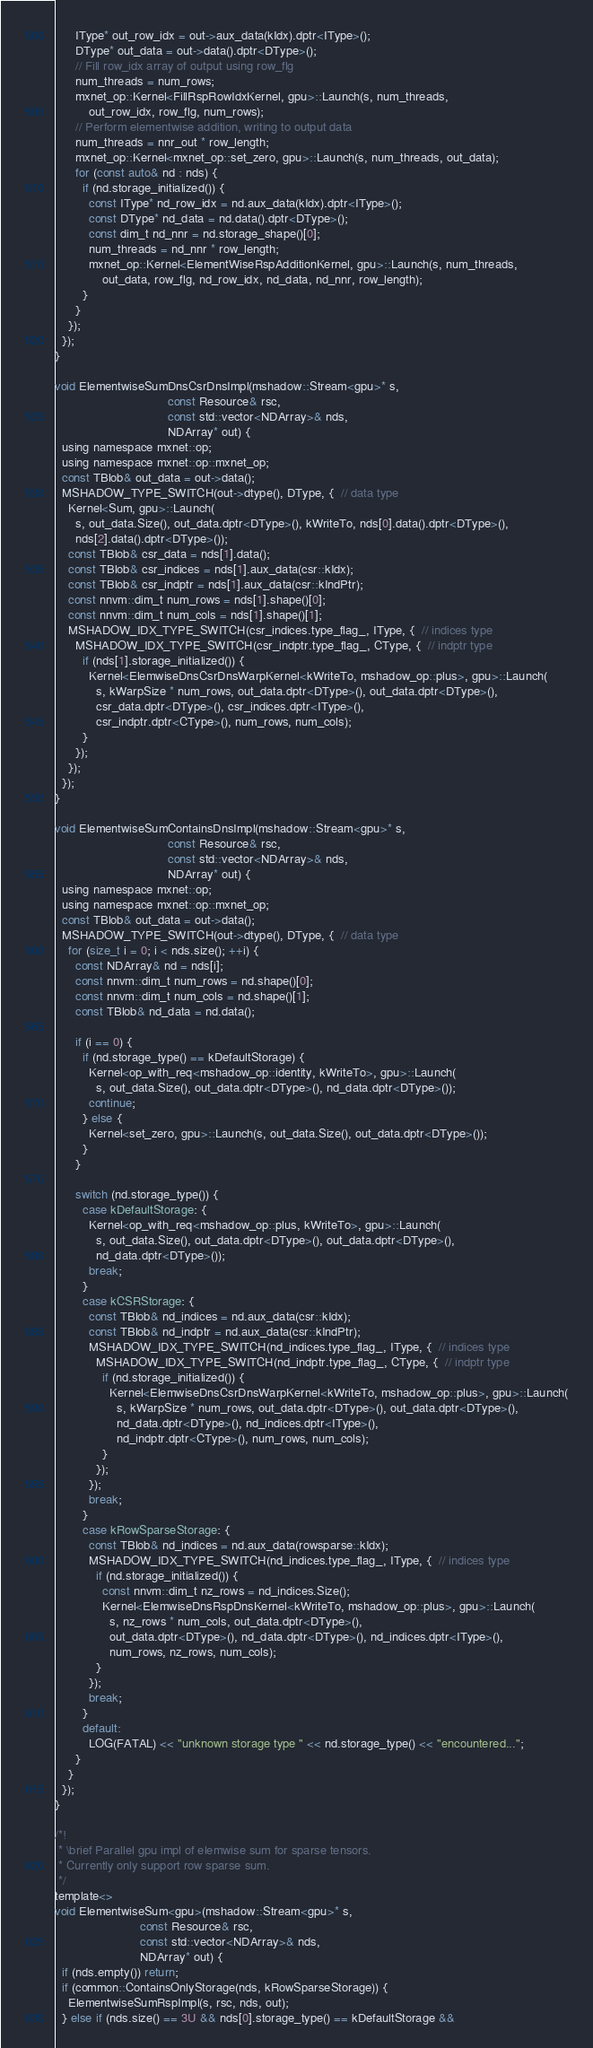Convert code to text. <code><loc_0><loc_0><loc_500><loc_500><_Cuda_>      IType* out_row_idx = out->aux_data(kIdx).dptr<IType>();
      DType* out_data = out->data().dptr<DType>();
      // Fill row_idx array of output using row_flg
      num_threads = num_rows;
      mxnet_op::Kernel<FillRspRowIdxKernel, gpu>::Launch(s, num_threads,
          out_row_idx, row_flg, num_rows);
      // Perform elementwise addition, writing to output data
      num_threads = nnr_out * row_length;
      mxnet_op::Kernel<mxnet_op::set_zero, gpu>::Launch(s, num_threads, out_data);
      for (const auto& nd : nds) {
        if (nd.storage_initialized()) {
          const IType* nd_row_idx = nd.aux_data(kIdx).dptr<IType>();
          const DType* nd_data = nd.data().dptr<DType>();
          const dim_t nd_nnr = nd.storage_shape()[0];
          num_threads = nd_nnr * row_length;
          mxnet_op::Kernel<ElementWiseRspAdditionKernel, gpu>::Launch(s, num_threads,
              out_data, row_flg, nd_row_idx, nd_data, nd_nnr, row_length);
        }
      }
    });
  });
}

void ElementwiseSumDnsCsrDnsImpl(mshadow::Stream<gpu>* s,
                                 const Resource& rsc,
                                 const std::vector<NDArray>& nds,
                                 NDArray* out) {
  using namespace mxnet::op;
  using namespace mxnet::op::mxnet_op;
  const TBlob& out_data = out->data();
  MSHADOW_TYPE_SWITCH(out->dtype(), DType, {  // data type
    Kernel<Sum, gpu>::Launch(
      s, out_data.Size(), out_data.dptr<DType>(), kWriteTo, nds[0].data().dptr<DType>(),
      nds[2].data().dptr<DType>());
    const TBlob& csr_data = nds[1].data();
    const TBlob& csr_indices = nds[1].aux_data(csr::kIdx);
    const TBlob& csr_indptr = nds[1].aux_data(csr::kIndPtr);
    const nnvm::dim_t num_rows = nds[1].shape()[0];
    const nnvm::dim_t num_cols = nds[1].shape()[1];
    MSHADOW_IDX_TYPE_SWITCH(csr_indices.type_flag_, IType, {  // indices type
      MSHADOW_IDX_TYPE_SWITCH(csr_indptr.type_flag_, CType, {  // indptr type
        if (nds[1].storage_initialized()) {
          Kernel<ElemwiseDnsCsrDnsWarpKernel<kWriteTo, mshadow_op::plus>, gpu>::Launch(
            s, kWarpSize * num_rows, out_data.dptr<DType>(), out_data.dptr<DType>(),
            csr_data.dptr<DType>(), csr_indices.dptr<IType>(),
            csr_indptr.dptr<CType>(), num_rows, num_cols);
        }
      });
    });
  });
}

void ElementwiseSumContainsDnsImpl(mshadow::Stream<gpu>* s,
                                 const Resource& rsc,
                                 const std::vector<NDArray>& nds,
                                 NDArray* out) {
  using namespace mxnet::op;
  using namespace mxnet::op::mxnet_op;
  const TBlob& out_data = out->data();
  MSHADOW_TYPE_SWITCH(out->dtype(), DType, {  // data type
    for (size_t i = 0; i < nds.size(); ++i) {
      const NDArray& nd = nds[i];
      const nnvm::dim_t num_rows = nd.shape()[0];
      const nnvm::dim_t num_cols = nd.shape()[1];
      const TBlob& nd_data = nd.data();

      if (i == 0) {
        if (nd.storage_type() == kDefaultStorage) {
          Kernel<op_with_req<mshadow_op::identity, kWriteTo>, gpu>::Launch(
            s, out_data.Size(), out_data.dptr<DType>(), nd_data.dptr<DType>());
          continue;
        } else {
          Kernel<set_zero, gpu>::Launch(s, out_data.Size(), out_data.dptr<DType>());
        }
      }

      switch (nd.storage_type()) {
        case kDefaultStorage: {
          Kernel<op_with_req<mshadow_op::plus, kWriteTo>, gpu>::Launch(
            s, out_data.Size(), out_data.dptr<DType>(), out_data.dptr<DType>(),
            nd_data.dptr<DType>());
          break;
        }
        case kCSRStorage: {
          const TBlob& nd_indices = nd.aux_data(csr::kIdx);
          const TBlob& nd_indptr = nd.aux_data(csr::kIndPtr);
          MSHADOW_IDX_TYPE_SWITCH(nd_indices.type_flag_, IType, {  // indices type
            MSHADOW_IDX_TYPE_SWITCH(nd_indptr.type_flag_, CType, {  // indptr type
              if (nd.storage_initialized()) {
                Kernel<ElemwiseDnsCsrDnsWarpKernel<kWriteTo, mshadow_op::plus>, gpu>::Launch(
                  s, kWarpSize * num_rows, out_data.dptr<DType>(), out_data.dptr<DType>(),
                  nd_data.dptr<DType>(), nd_indices.dptr<IType>(),
                  nd_indptr.dptr<CType>(), num_rows, num_cols);
              }
            });
          });
          break;
        }
        case kRowSparseStorage: {
          const TBlob& nd_indices = nd.aux_data(rowsparse::kIdx);
          MSHADOW_IDX_TYPE_SWITCH(nd_indices.type_flag_, IType, {  // indices type
            if (nd.storage_initialized()) {
              const nnvm::dim_t nz_rows = nd_indices.Size();
              Kernel<ElemwiseDnsRspDnsKernel<kWriteTo, mshadow_op::plus>, gpu>::Launch(
                s, nz_rows * num_cols, out_data.dptr<DType>(),
                out_data.dptr<DType>(), nd_data.dptr<DType>(), nd_indices.dptr<IType>(),
                num_rows, nz_rows, num_cols);
            }
          });
          break;
        }
        default:
          LOG(FATAL) << "unknown storage type " << nd.storage_type() << "encountered...";
      }
    }
  });
}

/*!
 * \brief Parallel gpu impl of elemwise sum for sparse tensors.
 * Currently only support row sparse sum.
 */
template<>
void ElementwiseSum<gpu>(mshadow::Stream<gpu>* s,
                         const Resource& rsc,
                         const std::vector<NDArray>& nds,
                         NDArray* out) {
  if (nds.empty()) return;
  if (common::ContainsOnlyStorage(nds, kRowSparseStorage)) {
    ElementwiseSumRspImpl(s, rsc, nds, out);
  } else if (nds.size() == 3U && nds[0].storage_type() == kDefaultStorage &&</code> 